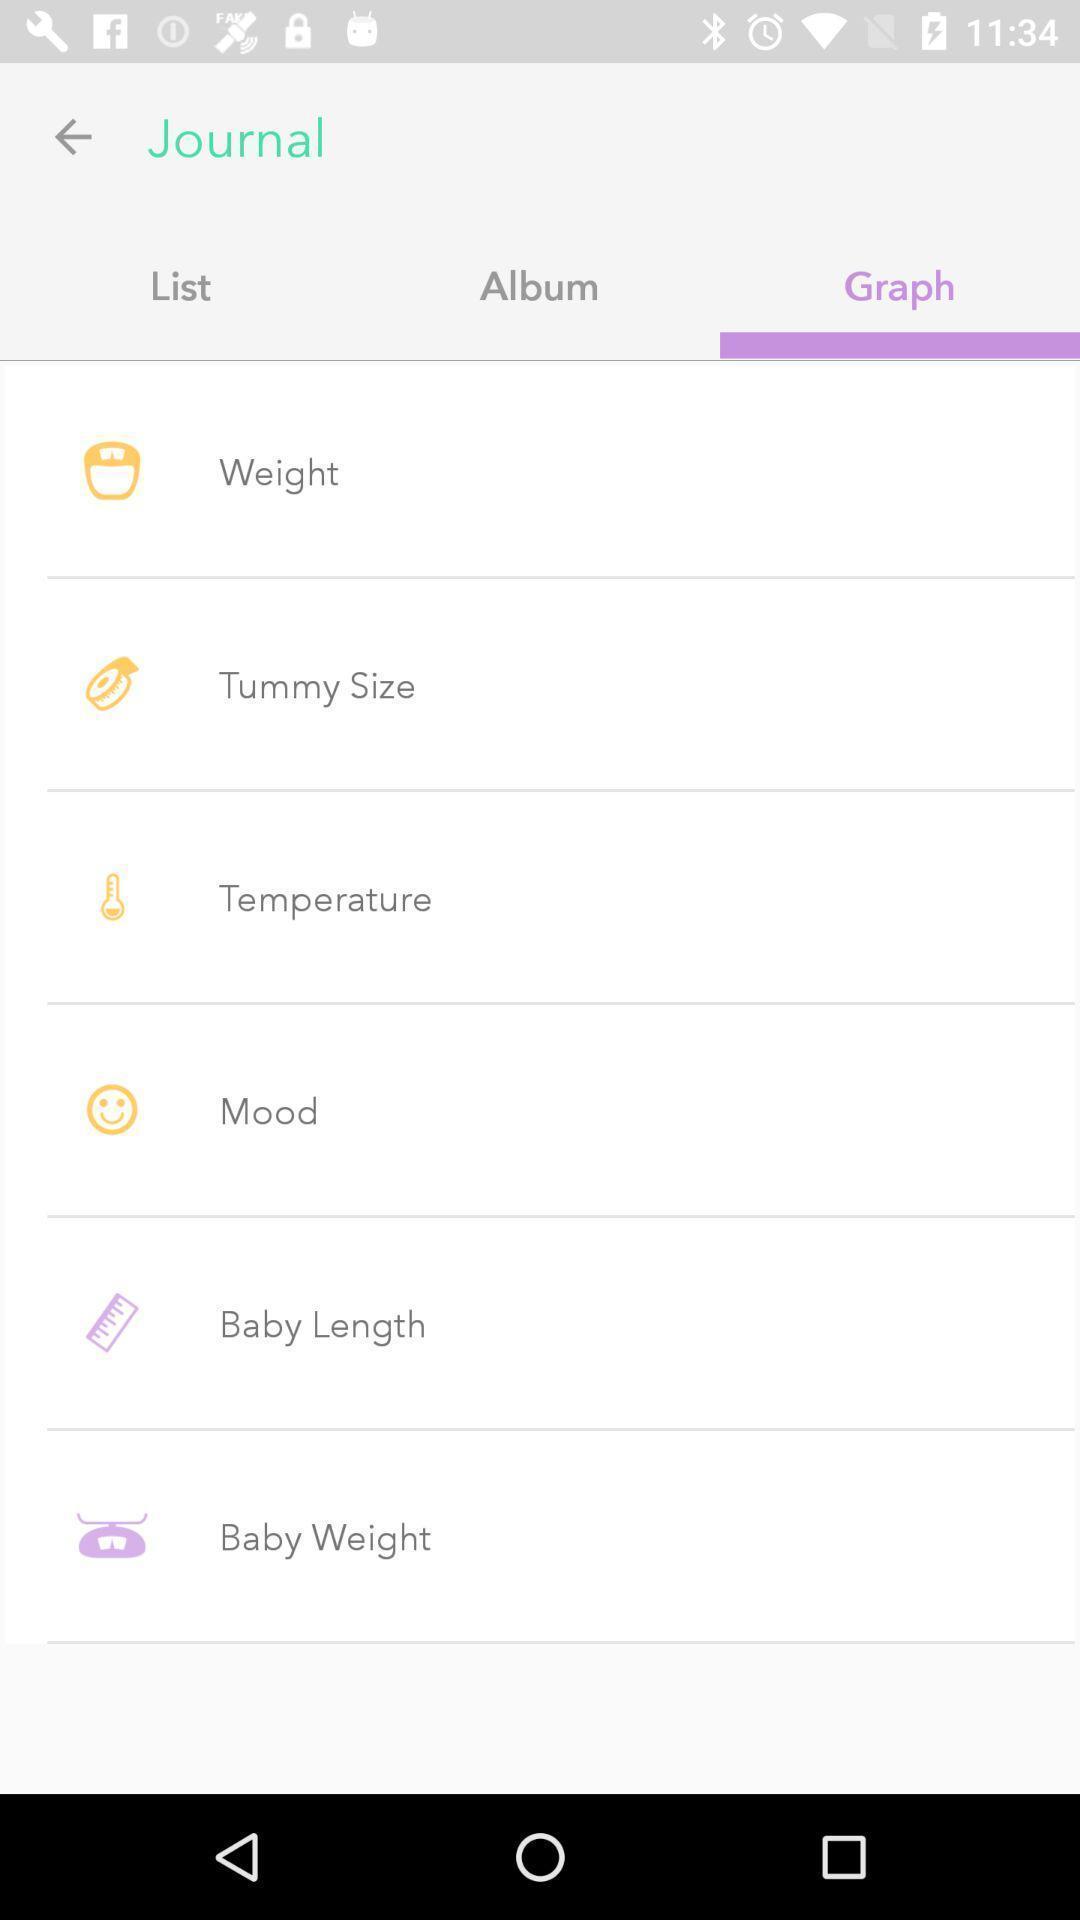What is the overall content of this screenshot? Screen displaying the list of options in a graph page. 